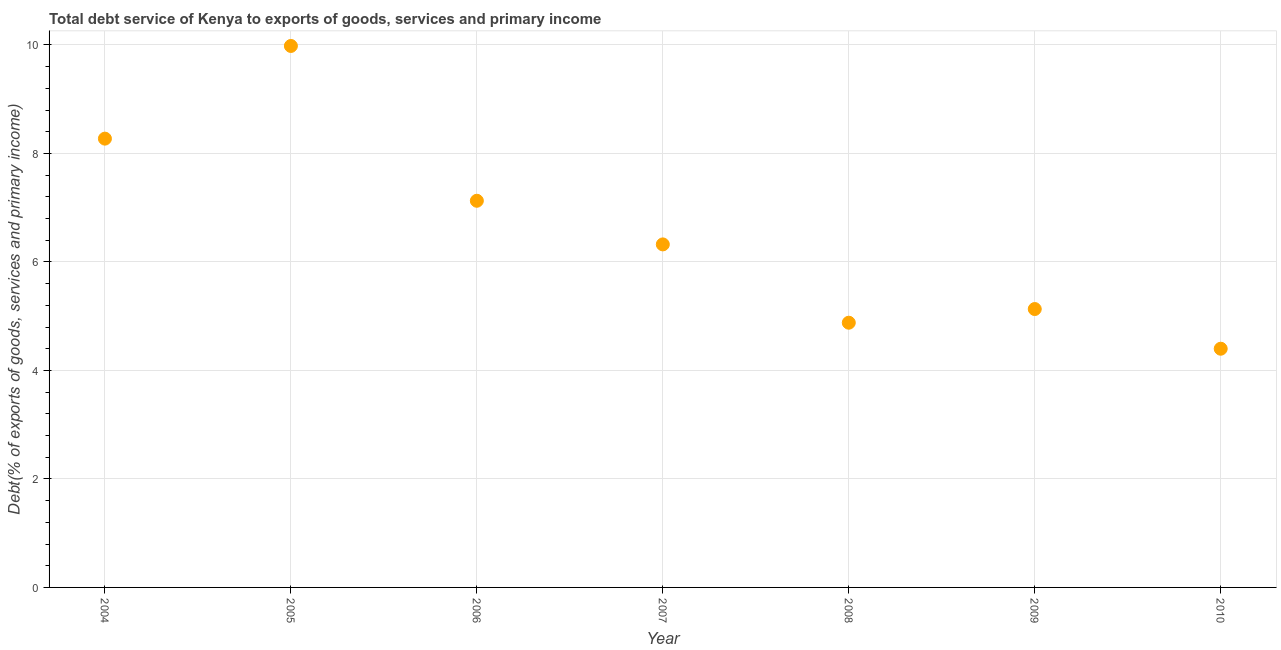What is the total debt service in 2008?
Give a very brief answer. 4.88. Across all years, what is the maximum total debt service?
Your response must be concise. 9.98. Across all years, what is the minimum total debt service?
Offer a very short reply. 4.4. In which year was the total debt service maximum?
Provide a short and direct response. 2005. In which year was the total debt service minimum?
Make the answer very short. 2010. What is the sum of the total debt service?
Your answer should be compact. 46.12. What is the difference between the total debt service in 2005 and 2009?
Provide a succinct answer. 4.85. What is the average total debt service per year?
Make the answer very short. 6.59. What is the median total debt service?
Keep it short and to the point. 6.32. Do a majority of the years between 2005 and 2008 (inclusive) have total debt service greater than 5.6 %?
Provide a short and direct response. Yes. What is the ratio of the total debt service in 2004 to that in 2009?
Offer a very short reply. 1.61. Is the total debt service in 2006 less than that in 2007?
Offer a terse response. No. What is the difference between the highest and the second highest total debt service?
Your response must be concise. 1.71. Is the sum of the total debt service in 2005 and 2008 greater than the maximum total debt service across all years?
Offer a very short reply. Yes. What is the difference between the highest and the lowest total debt service?
Give a very brief answer. 5.58. Does the total debt service monotonically increase over the years?
Make the answer very short. No. How many dotlines are there?
Ensure brevity in your answer.  1. Does the graph contain grids?
Your response must be concise. Yes. What is the title of the graph?
Offer a very short reply. Total debt service of Kenya to exports of goods, services and primary income. What is the label or title of the Y-axis?
Ensure brevity in your answer.  Debt(% of exports of goods, services and primary income). What is the Debt(% of exports of goods, services and primary income) in 2004?
Your response must be concise. 8.27. What is the Debt(% of exports of goods, services and primary income) in 2005?
Ensure brevity in your answer.  9.98. What is the Debt(% of exports of goods, services and primary income) in 2006?
Make the answer very short. 7.13. What is the Debt(% of exports of goods, services and primary income) in 2007?
Provide a short and direct response. 6.32. What is the Debt(% of exports of goods, services and primary income) in 2008?
Ensure brevity in your answer.  4.88. What is the Debt(% of exports of goods, services and primary income) in 2009?
Give a very brief answer. 5.13. What is the Debt(% of exports of goods, services and primary income) in 2010?
Give a very brief answer. 4.4. What is the difference between the Debt(% of exports of goods, services and primary income) in 2004 and 2005?
Offer a very short reply. -1.71. What is the difference between the Debt(% of exports of goods, services and primary income) in 2004 and 2006?
Your response must be concise. 1.15. What is the difference between the Debt(% of exports of goods, services and primary income) in 2004 and 2007?
Provide a succinct answer. 1.95. What is the difference between the Debt(% of exports of goods, services and primary income) in 2004 and 2008?
Offer a very short reply. 3.39. What is the difference between the Debt(% of exports of goods, services and primary income) in 2004 and 2009?
Your answer should be very brief. 3.14. What is the difference between the Debt(% of exports of goods, services and primary income) in 2004 and 2010?
Ensure brevity in your answer.  3.87. What is the difference between the Debt(% of exports of goods, services and primary income) in 2005 and 2006?
Keep it short and to the point. 2.85. What is the difference between the Debt(% of exports of goods, services and primary income) in 2005 and 2007?
Make the answer very short. 3.66. What is the difference between the Debt(% of exports of goods, services and primary income) in 2005 and 2008?
Your answer should be compact. 5.1. What is the difference between the Debt(% of exports of goods, services and primary income) in 2005 and 2009?
Offer a very short reply. 4.85. What is the difference between the Debt(% of exports of goods, services and primary income) in 2005 and 2010?
Provide a succinct answer. 5.58. What is the difference between the Debt(% of exports of goods, services and primary income) in 2006 and 2007?
Your response must be concise. 0.8. What is the difference between the Debt(% of exports of goods, services and primary income) in 2006 and 2008?
Your response must be concise. 2.25. What is the difference between the Debt(% of exports of goods, services and primary income) in 2006 and 2009?
Offer a terse response. 2. What is the difference between the Debt(% of exports of goods, services and primary income) in 2006 and 2010?
Provide a succinct answer. 2.73. What is the difference between the Debt(% of exports of goods, services and primary income) in 2007 and 2008?
Your response must be concise. 1.44. What is the difference between the Debt(% of exports of goods, services and primary income) in 2007 and 2009?
Your answer should be compact. 1.19. What is the difference between the Debt(% of exports of goods, services and primary income) in 2007 and 2010?
Keep it short and to the point. 1.92. What is the difference between the Debt(% of exports of goods, services and primary income) in 2008 and 2009?
Your answer should be very brief. -0.25. What is the difference between the Debt(% of exports of goods, services and primary income) in 2008 and 2010?
Offer a terse response. 0.48. What is the difference between the Debt(% of exports of goods, services and primary income) in 2009 and 2010?
Your response must be concise. 0.73. What is the ratio of the Debt(% of exports of goods, services and primary income) in 2004 to that in 2005?
Provide a short and direct response. 0.83. What is the ratio of the Debt(% of exports of goods, services and primary income) in 2004 to that in 2006?
Give a very brief answer. 1.16. What is the ratio of the Debt(% of exports of goods, services and primary income) in 2004 to that in 2007?
Offer a very short reply. 1.31. What is the ratio of the Debt(% of exports of goods, services and primary income) in 2004 to that in 2008?
Make the answer very short. 1.7. What is the ratio of the Debt(% of exports of goods, services and primary income) in 2004 to that in 2009?
Provide a succinct answer. 1.61. What is the ratio of the Debt(% of exports of goods, services and primary income) in 2004 to that in 2010?
Your answer should be very brief. 1.88. What is the ratio of the Debt(% of exports of goods, services and primary income) in 2005 to that in 2006?
Provide a short and direct response. 1.4. What is the ratio of the Debt(% of exports of goods, services and primary income) in 2005 to that in 2007?
Provide a short and direct response. 1.58. What is the ratio of the Debt(% of exports of goods, services and primary income) in 2005 to that in 2008?
Your response must be concise. 2.04. What is the ratio of the Debt(% of exports of goods, services and primary income) in 2005 to that in 2009?
Ensure brevity in your answer.  1.95. What is the ratio of the Debt(% of exports of goods, services and primary income) in 2005 to that in 2010?
Your response must be concise. 2.27. What is the ratio of the Debt(% of exports of goods, services and primary income) in 2006 to that in 2007?
Make the answer very short. 1.13. What is the ratio of the Debt(% of exports of goods, services and primary income) in 2006 to that in 2008?
Offer a very short reply. 1.46. What is the ratio of the Debt(% of exports of goods, services and primary income) in 2006 to that in 2009?
Provide a succinct answer. 1.39. What is the ratio of the Debt(% of exports of goods, services and primary income) in 2006 to that in 2010?
Keep it short and to the point. 1.62. What is the ratio of the Debt(% of exports of goods, services and primary income) in 2007 to that in 2008?
Ensure brevity in your answer.  1.3. What is the ratio of the Debt(% of exports of goods, services and primary income) in 2007 to that in 2009?
Give a very brief answer. 1.23. What is the ratio of the Debt(% of exports of goods, services and primary income) in 2007 to that in 2010?
Offer a terse response. 1.44. What is the ratio of the Debt(% of exports of goods, services and primary income) in 2008 to that in 2009?
Give a very brief answer. 0.95. What is the ratio of the Debt(% of exports of goods, services and primary income) in 2008 to that in 2010?
Your response must be concise. 1.11. What is the ratio of the Debt(% of exports of goods, services and primary income) in 2009 to that in 2010?
Your answer should be compact. 1.17. 